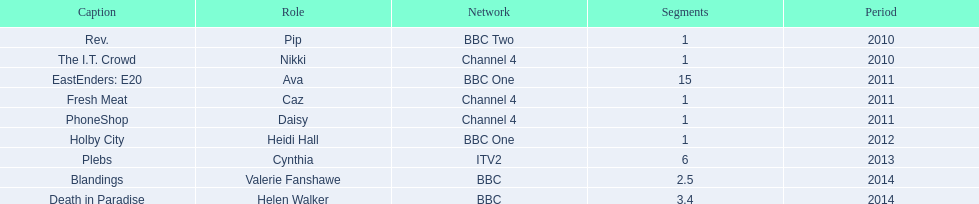What was the previous role this actress played before playing cynthia in plebs? Heidi Hall. 